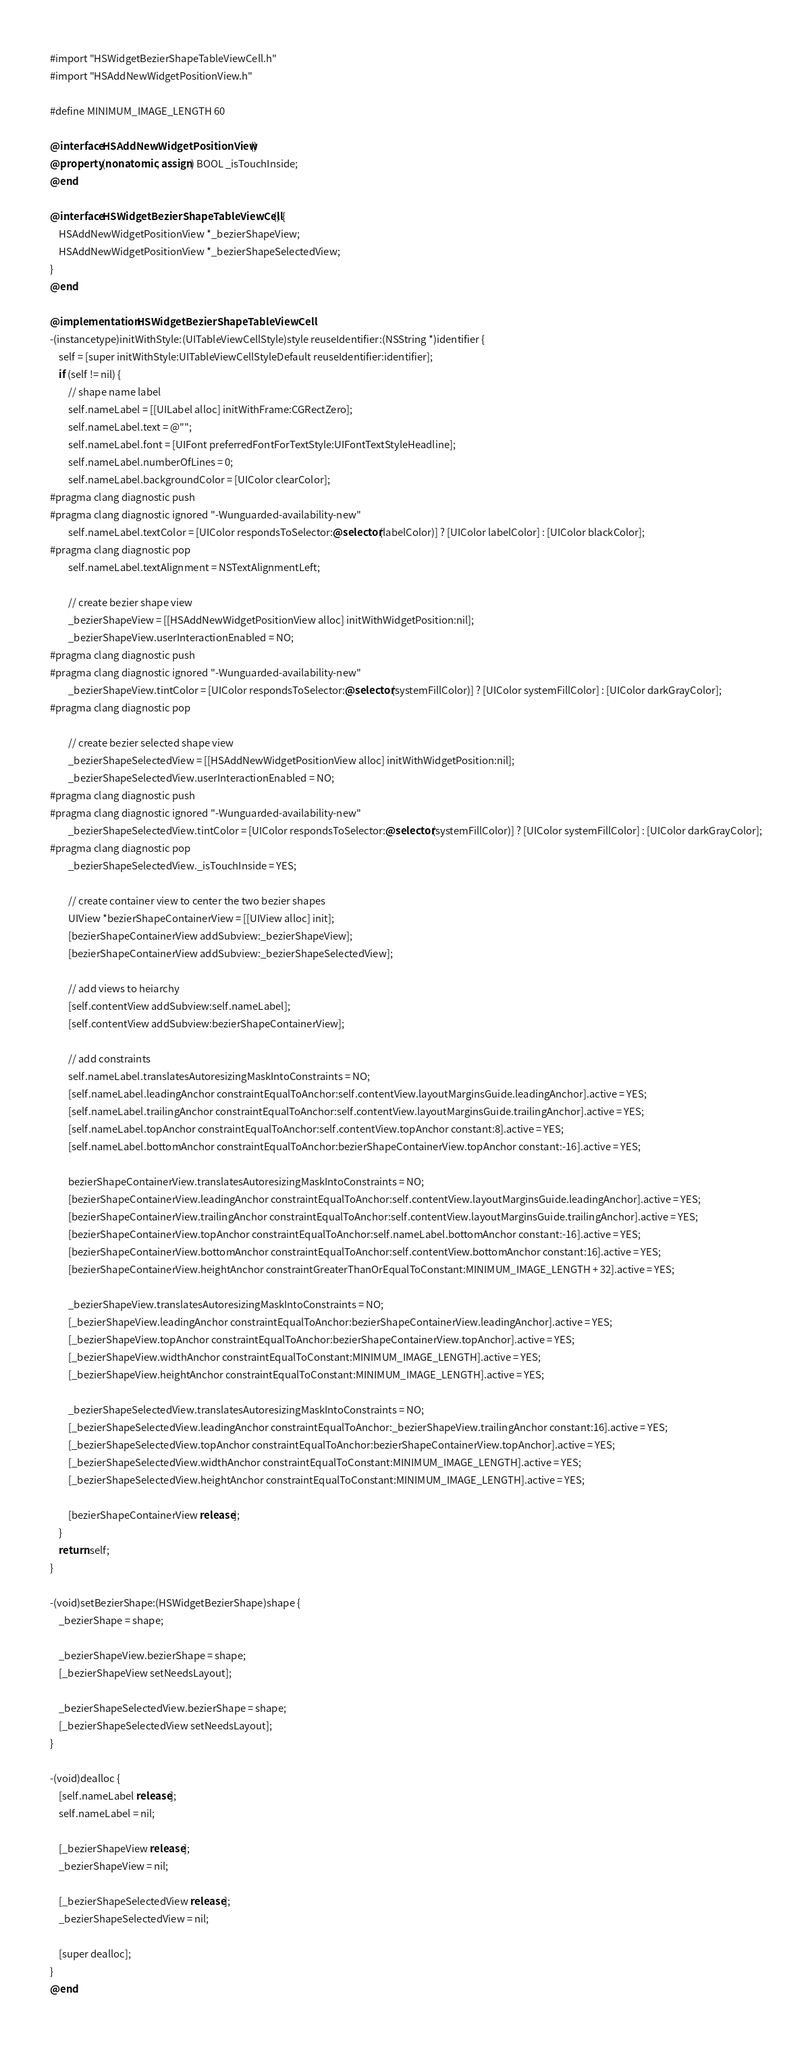<code> <loc_0><loc_0><loc_500><loc_500><_ObjectiveC_>#import "HSWidgetBezierShapeTableViewCell.h"
#import "HSAddNewWidgetPositionView.h"

#define MINIMUM_IMAGE_LENGTH 60

@interface HSAddNewWidgetPositionView ()
@property (nonatomic, assign) BOOL _isTouchInside;
@end

@interface HSWidgetBezierShapeTableViewCell () {
	HSAddNewWidgetPositionView *_bezierShapeView;
	HSAddNewWidgetPositionView *_bezierShapeSelectedView;
}
@end

@implementation HSWidgetBezierShapeTableViewCell
-(instancetype)initWithStyle:(UITableViewCellStyle)style reuseIdentifier:(NSString *)identifier {
	self = [super initWithStyle:UITableViewCellStyleDefault reuseIdentifier:identifier];
	if (self != nil) {
		// shape name label
		self.nameLabel = [[UILabel alloc] initWithFrame:CGRectZero];
		self.nameLabel.text = @"";
		self.nameLabel.font = [UIFont preferredFontForTextStyle:UIFontTextStyleHeadline];
		self.nameLabel.numberOfLines = 0;
		self.nameLabel.backgroundColor = [UIColor clearColor];
#pragma clang diagnostic push
#pragma clang diagnostic ignored "-Wunguarded-availability-new"
		self.nameLabel.textColor = [UIColor respondsToSelector:@selector(labelColor)] ? [UIColor labelColor] : [UIColor blackColor];
#pragma clang diagnostic pop
		self.nameLabel.textAlignment = NSTextAlignmentLeft;

		// create bezier shape view
		_bezierShapeView = [[HSAddNewWidgetPositionView alloc] initWithWidgetPosition:nil];
		_bezierShapeView.userInteractionEnabled = NO;
#pragma clang diagnostic push
#pragma clang diagnostic ignored "-Wunguarded-availability-new"
		_bezierShapeView.tintColor = [UIColor respondsToSelector:@selector(systemFillColor)] ? [UIColor systemFillColor] : [UIColor darkGrayColor];
#pragma clang diagnostic pop

		// create bezier selected shape view
		_bezierShapeSelectedView = [[HSAddNewWidgetPositionView alloc] initWithWidgetPosition:nil];
		_bezierShapeSelectedView.userInteractionEnabled = NO;
#pragma clang diagnostic push
#pragma clang diagnostic ignored "-Wunguarded-availability-new"
		_bezierShapeSelectedView.tintColor = [UIColor respondsToSelector:@selector(systemFillColor)] ? [UIColor systemFillColor] : [UIColor darkGrayColor];
#pragma clang diagnostic pop
		_bezierShapeSelectedView._isTouchInside = YES;

		// create container view to center the two bezier shapes
		UIView *bezierShapeContainerView = [[UIView alloc] init];
		[bezierShapeContainerView addSubview:_bezierShapeView];
		[bezierShapeContainerView addSubview:_bezierShapeSelectedView];

		// add views to heiarchy
		[self.contentView addSubview:self.nameLabel];
		[self.contentView addSubview:bezierShapeContainerView];

		// add constraints
		self.nameLabel.translatesAutoresizingMaskIntoConstraints = NO;
		[self.nameLabel.leadingAnchor constraintEqualToAnchor:self.contentView.layoutMarginsGuide.leadingAnchor].active = YES;
		[self.nameLabel.trailingAnchor constraintEqualToAnchor:self.contentView.layoutMarginsGuide.trailingAnchor].active = YES;
		[self.nameLabel.topAnchor constraintEqualToAnchor:self.contentView.topAnchor constant:8].active = YES;
		[self.nameLabel.bottomAnchor constraintEqualToAnchor:bezierShapeContainerView.topAnchor constant:-16].active = YES;

		bezierShapeContainerView.translatesAutoresizingMaskIntoConstraints = NO;
		[bezierShapeContainerView.leadingAnchor constraintEqualToAnchor:self.contentView.layoutMarginsGuide.leadingAnchor].active = YES;
		[bezierShapeContainerView.trailingAnchor constraintEqualToAnchor:self.contentView.layoutMarginsGuide.trailingAnchor].active = YES;
		[bezierShapeContainerView.topAnchor constraintEqualToAnchor:self.nameLabel.bottomAnchor constant:-16].active = YES;
		[bezierShapeContainerView.bottomAnchor constraintEqualToAnchor:self.contentView.bottomAnchor constant:16].active = YES;
		[bezierShapeContainerView.heightAnchor constraintGreaterThanOrEqualToConstant:MINIMUM_IMAGE_LENGTH + 32].active = YES;

		_bezierShapeView.translatesAutoresizingMaskIntoConstraints = NO;
		[_bezierShapeView.leadingAnchor constraintEqualToAnchor:bezierShapeContainerView.leadingAnchor].active = YES;
		[_bezierShapeView.topAnchor constraintEqualToAnchor:bezierShapeContainerView.topAnchor].active = YES;
		[_bezierShapeView.widthAnchor constraintEqualToConstant:MINIMUM_IMAGE_LENGTH].active = YES;
		[_bezierShapeView.heightAnchor constraintEqualToConstant:MINIMUM_IMAGE_LENGTH].active = YES;

		_bezierShapeSelectedView.translatesAutoresizingMaskIntoConstraints = NO;
		[_bezierShapeSelectedView.leadingAnchor constraintEqualToAnchor:_bezierShapeView.trailingAnchor constant:16].active = YES;
		[_bezierShapeSelectedView.topAnchor constraintEqualToAnchor:bezierShapeContainerView.topAnchor].active = YES;
		[_bezierShapeSelectedView.widthAnchor constraintEqualToConstant:MINIMUM_IMAGE_LENGTH].active = YES;
		[_bezierShapeSelectedView.heightAnchor constraintEqualToConstant:MINIMUM_IMAGE_LENGTH].active = YES;

		[bezierShapeContainerView release];
	}
	return self;
}

-(void)setBezierShape:(HSWidgetBezierShape)shape {
	_bezierShape = shape;

	_bezierShapeView.bezierShape = shape;
	[_bezierShapeView setNeedsLayout];

	_bezierShapeSelectedView.bezierShape = shape;
	[_bezierShapeSelectedView setNeedsLayout];
}

-(void)dealloc {
	[self.nameLabel release];
	self.nameLabel = nil;

	[_bezierShapeView release];
	_bezierShapeView = nil;

	[_bezierShapeSelectedView release];
	_bezierShapeSelectedView = nil;

	[super dealloc];
}
@end</code> 